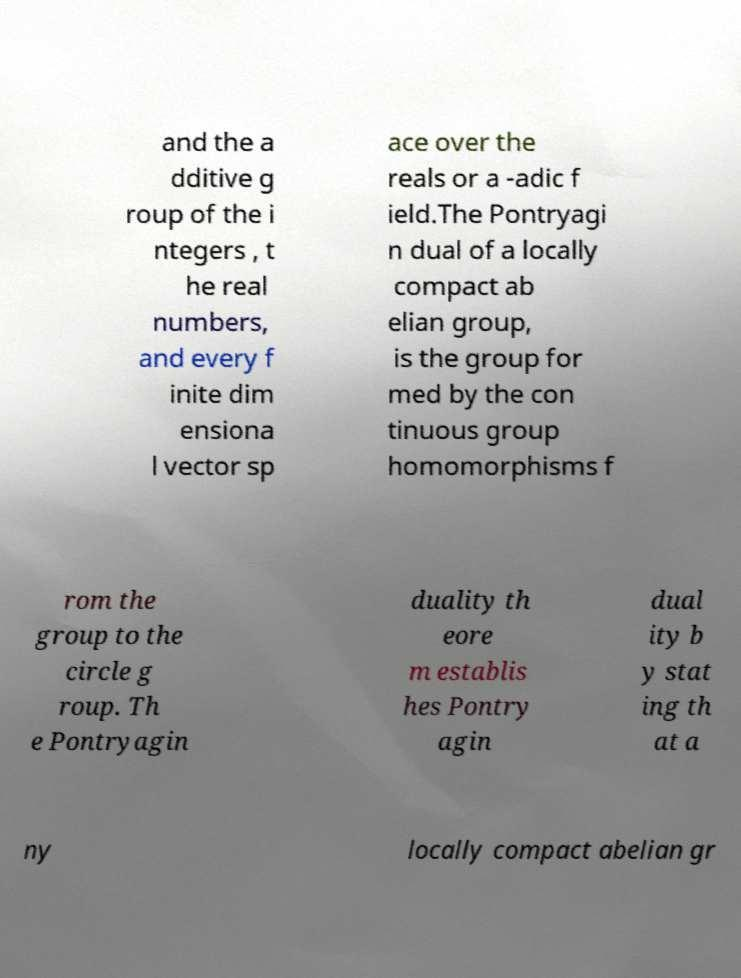Please read and relay the text visible in this image. What does it say? and the a dditive g roup of the i ntegers , t he real numbers, and every f inite dim ensiona l vector sp ace over the reals or a -adic f ield.The Pontryagi n dual of a locally compact ab elian group, is the group for med by the con tinuous group homomorphisms f rom the group to the circle g roup. Th e Pontryagin duality th eore m establis hes Pontry agin dual ity b y stat ing th at a ny locally compact abelian gr 